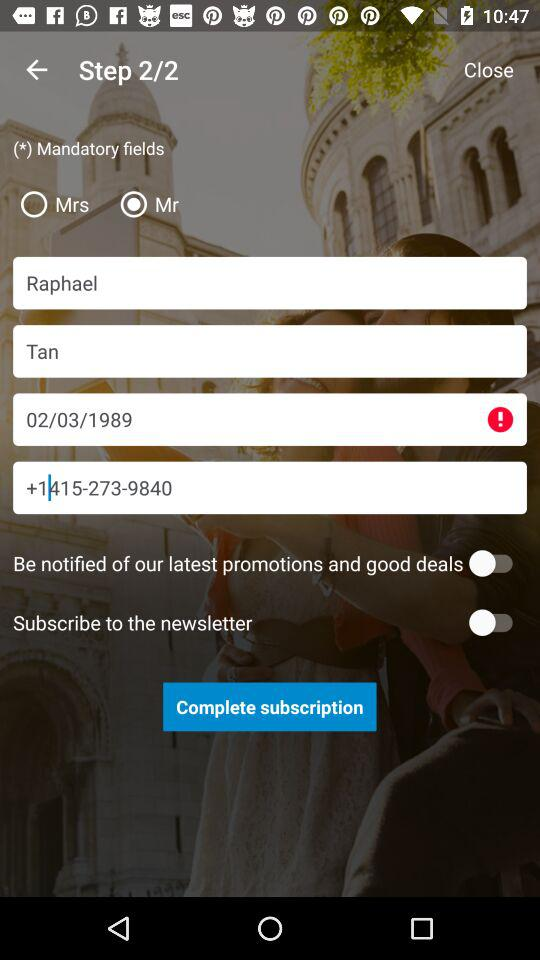Which option is selected? The selected option is "Mr". 